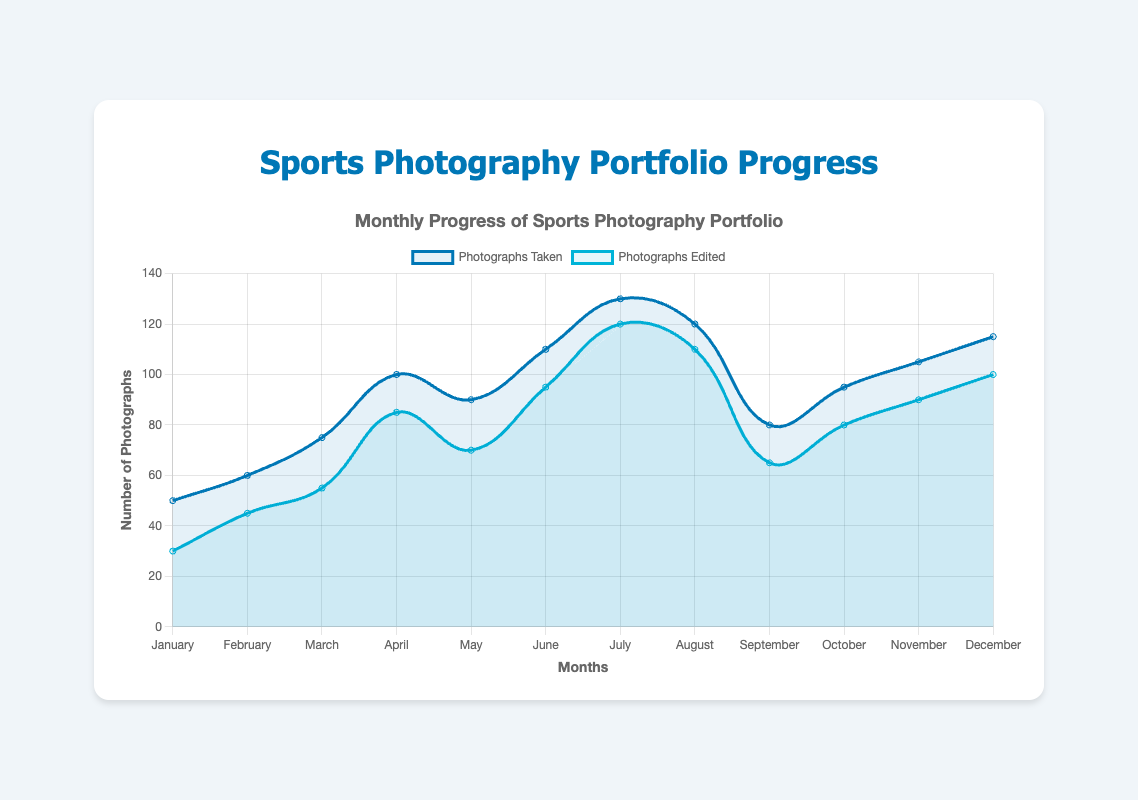Which month had the highest number of photographs taken? By looking at the peaks of the line representing 'Photographs Taken,' we can identify the highest point. The highest number of photographs taken occurs in July, reaching 130.
Answer: July In which month was the difference between photographs taken and photographs edited the smallest? To find this, we need to identify the smallest gap between the two lines on the chart. This difference is smallest in July, where the numbers are 130 (taken) and 120 (edited), making the difference 10.
Answer: July Which months saw a decline in the number of photographs taken compared to the previous month? We need to look at the decreasing sections of the 'Photographs Taken' line. Declines occurred from August to September (120 to 80) and from June to July (110 to 130 - 0 reduction). Therefore, only August to September saw a genuine decline.
Answer: September By how much did the number of photographs edited increase from January to December? Subtract the number in January from the number in December for 'Photographs Edited': 100 - 30 = 70.
Answer: 70 Which month had the highest number of photographs edited? By identifying the peak of the 'Photographs Edited' line, we find the highest point. This occurs in July, with 120 photographs edited.
Answer: July How many photographs were taken and edited in June combined? Sum the 'Photographs Taken' and 'Photographs Edited' values for June: 110 + 95 = 205.
Answer: 205 Was there any month where the number of photographs edited exceeded the number taken? By comparing the two lines month by month, we observe that in every month, the number of photographs taken is higher than those edited.
Answer: No What's the average number of photographs edited per month? Add up the monthly values of 'Photographs Edited' and divide by 12: (30 + 45 + 55 + 85 + 70 + 95 + 120 + 110 + 65 + 80 + 90 + 100) / 12 = 78.58.
Answer: 78.58 In which month did the number of photographs taken increase the most compared to the previous month? Find the month with the largest difference between successive months for 'Photographs Taken'. The biggest increase is from March to April (75 to 100), a difference of 25.
Answer: April 